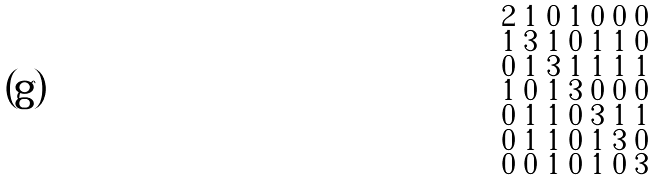<formula> <loc_0><loc_0><loc_500><loc_500>\begin{smallmatrix} 2 & 1 & 0 & 1 & 0 & 0 & 0 \\ 1 & 3 & 1 & 0 & 1 & 1 & 0 \\ 0 & 1 & 3 & 1 & 1 & 1 & 1 \\ 1 & 0 & 1 & 3 & 0 & 0 & 0 \\ 0 & 1 & 1 & 0 & 3 & 1 & 1 \\ 0 & 1 & 1 & 0 & 1 & 3 & 0 \\ 0 & 0 & 1 & 0 & 1 & 0 & 3 \end{smallmatrix}</formula> 